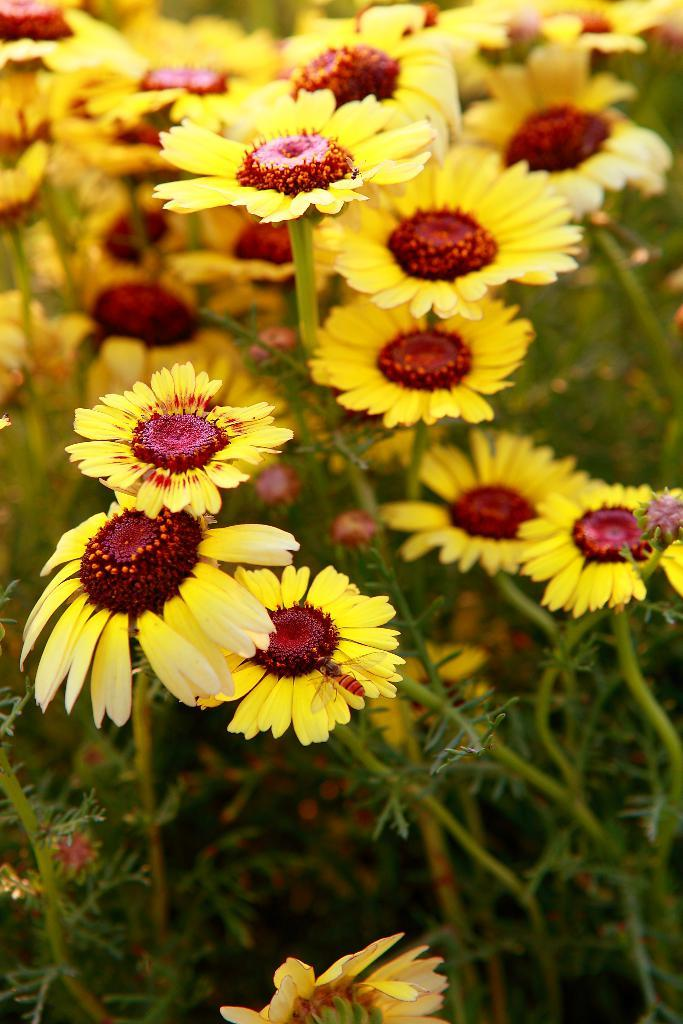What type of living organisms can be seen in the image? There are flowers and plants visible in the image. Can you describe the plants in the image? The plants in the image are not specified, but they are present alongside the flowers. What type of marble is visible in the image? There is no marble present in the image; it features flowers and plants. What kind of shoes can be seen on the flowers in the image? There are no shoes present in the image, as flowers and plants do not have the ability to wear shoes. 